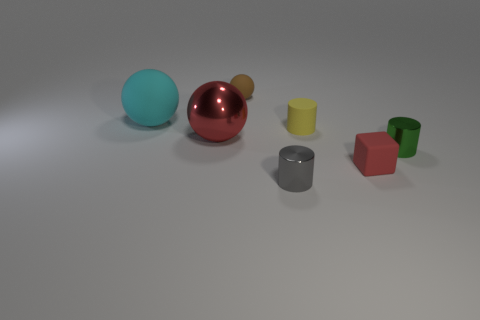Do the block and the sphere that is in front of the large cyan rubber thing have the same color?
Make the answer very short. Yes. Is the number of metallic cylinders that are on the left side of the small ball the same as the number of tiny shiny cylinders that are to the left of the tiny yellow matte cylinder?
Offer a very short reply. No. There is a cylinder that is on the right side of the cube; what is its material?
Offer a very short reply. Metal. What number of things are either shiny cylinders right of the yellow rubber cylinder or red matte things?
Provide a short and direct response. 2. What number of other objects are there of the same shape as the tiny red matte thing?
Keep it short and to the point. 0. Does the big shiny object that is behind the small green metallic thing have the same shape as the big cyan rubber thing?
Keep it short and to the point. Yes. There is a big cyan ball; are there any cubes to the right of it?
Ensure brevity in your answer.  Yes. How many small things are purple things or green metallic cylinders?
Give a very brief answer. 1. Does the small ball have the same material as the red ball?
Offer a very short reply. No. The rubber cube that is the same color as the big metal ball is what size?
Make the answer very short. Small. 